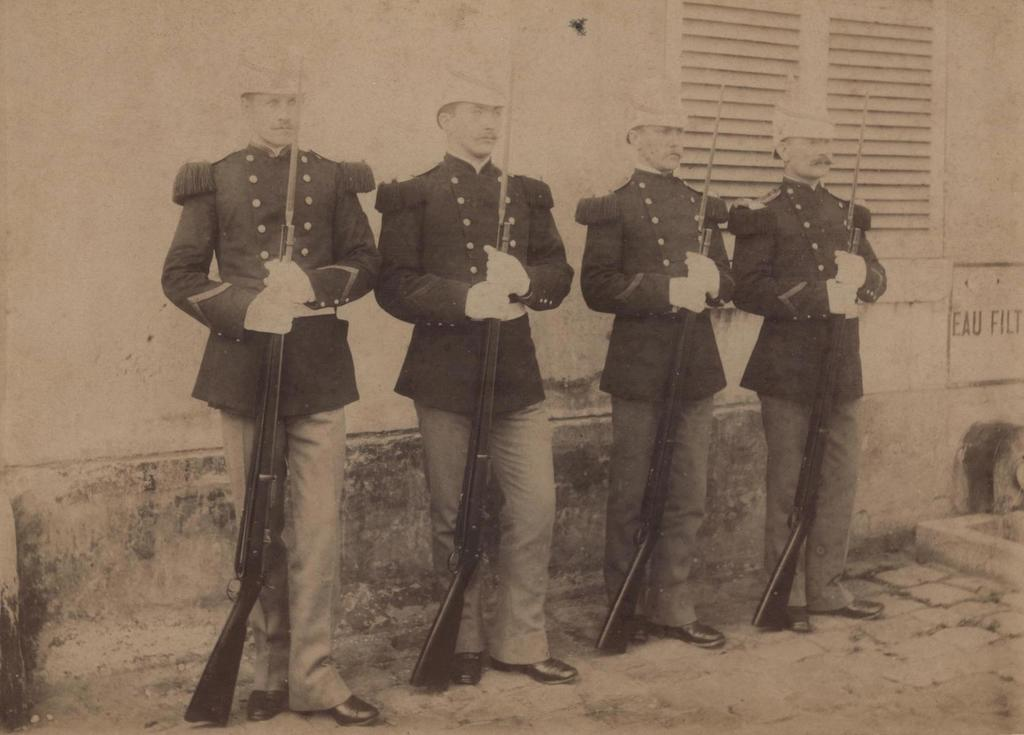What is the color scheme of the image? The image is black and white. How many men are present in the image? There are 4 men in the image. What are the men wearing? The men are wearing uniforms. What are the men holding in their hands? The men are holding guns. What can be seen in the background of the image? There is a window visible in the image. What type of twig can be seen in the hands of the men in the image? There are no twigs present in the image; the men are holding guns. What crime is being committed in the image? There is no indication of a crime being committed in the image; it simply shows 4 men holding guns. 